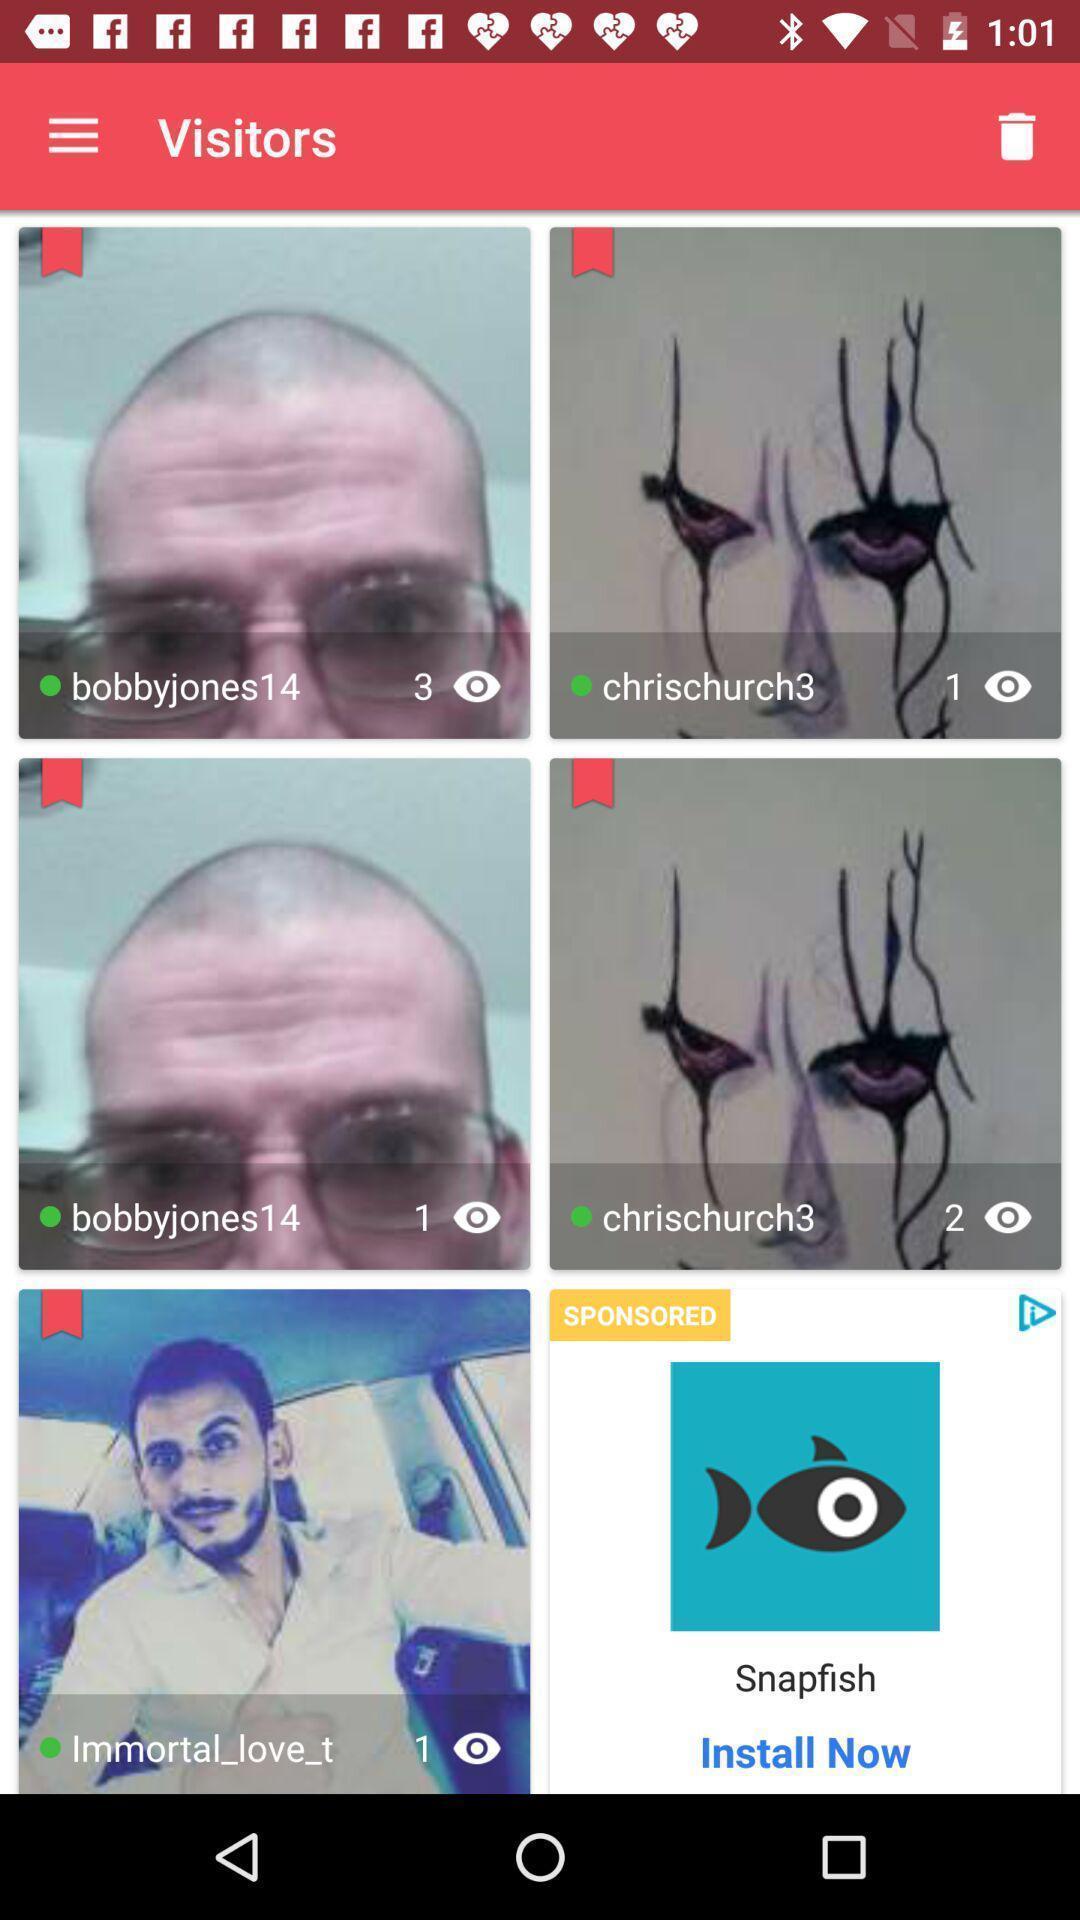Describe this image in words. Screen displaying multiple user profile information with pictures. 